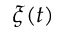<formula> <loc_0><loc_0><loc_500><loc_500>\xi ( t )</formula> 